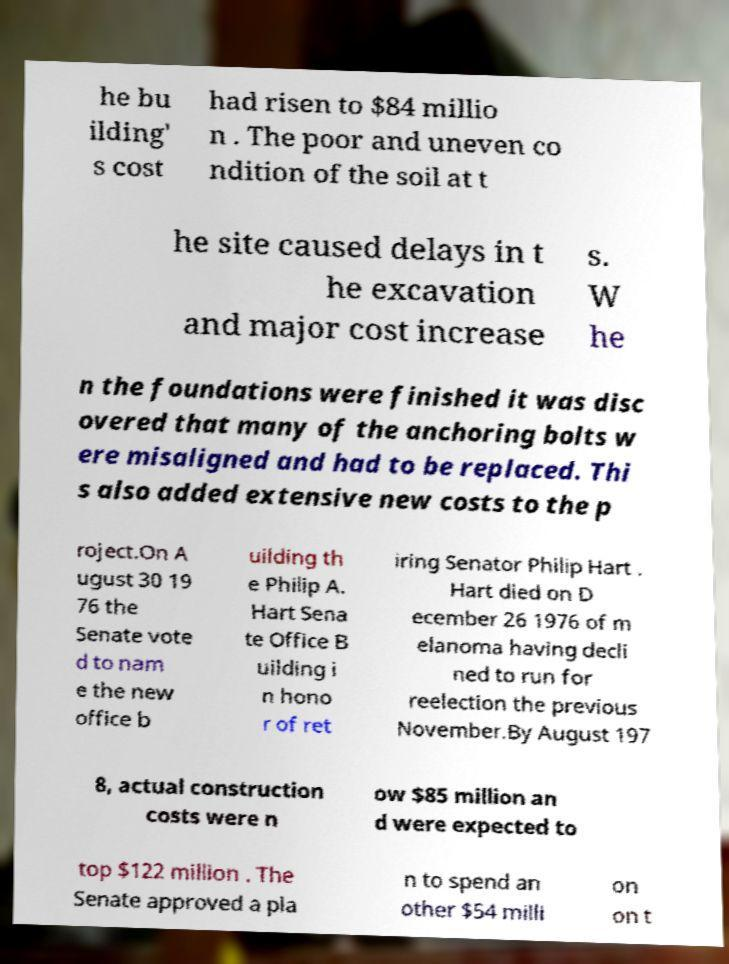What messages or text are displayed in this image? I need them in a readable, typed format. he bu ilding' s cost had risen to $84 millio n . The poor and uneven co ndition of the soil at t he site caused delays in t he excavation and major cost increase s. W he n the foundations were finished it was disc overed that many of the anchoring bolts w ere misaligned and had to be replaced. Thi s also added extensive new costs to the p roject.On A ugust 30 19 76 the Senate vote d to nam e the new office b uilding th e Philip A. Hart Sena te Office B uilding i n hono r of ret iring Senator Philip Hart . Hart died on D ecember 26 1976 of m elanoma having decli ned to run for reelection the previous November.By August 197 8, actual construction costs were n ow $85 million an d were expected to top $122 million . The Senate approved a pla n to spend an other $54 milli on on t 